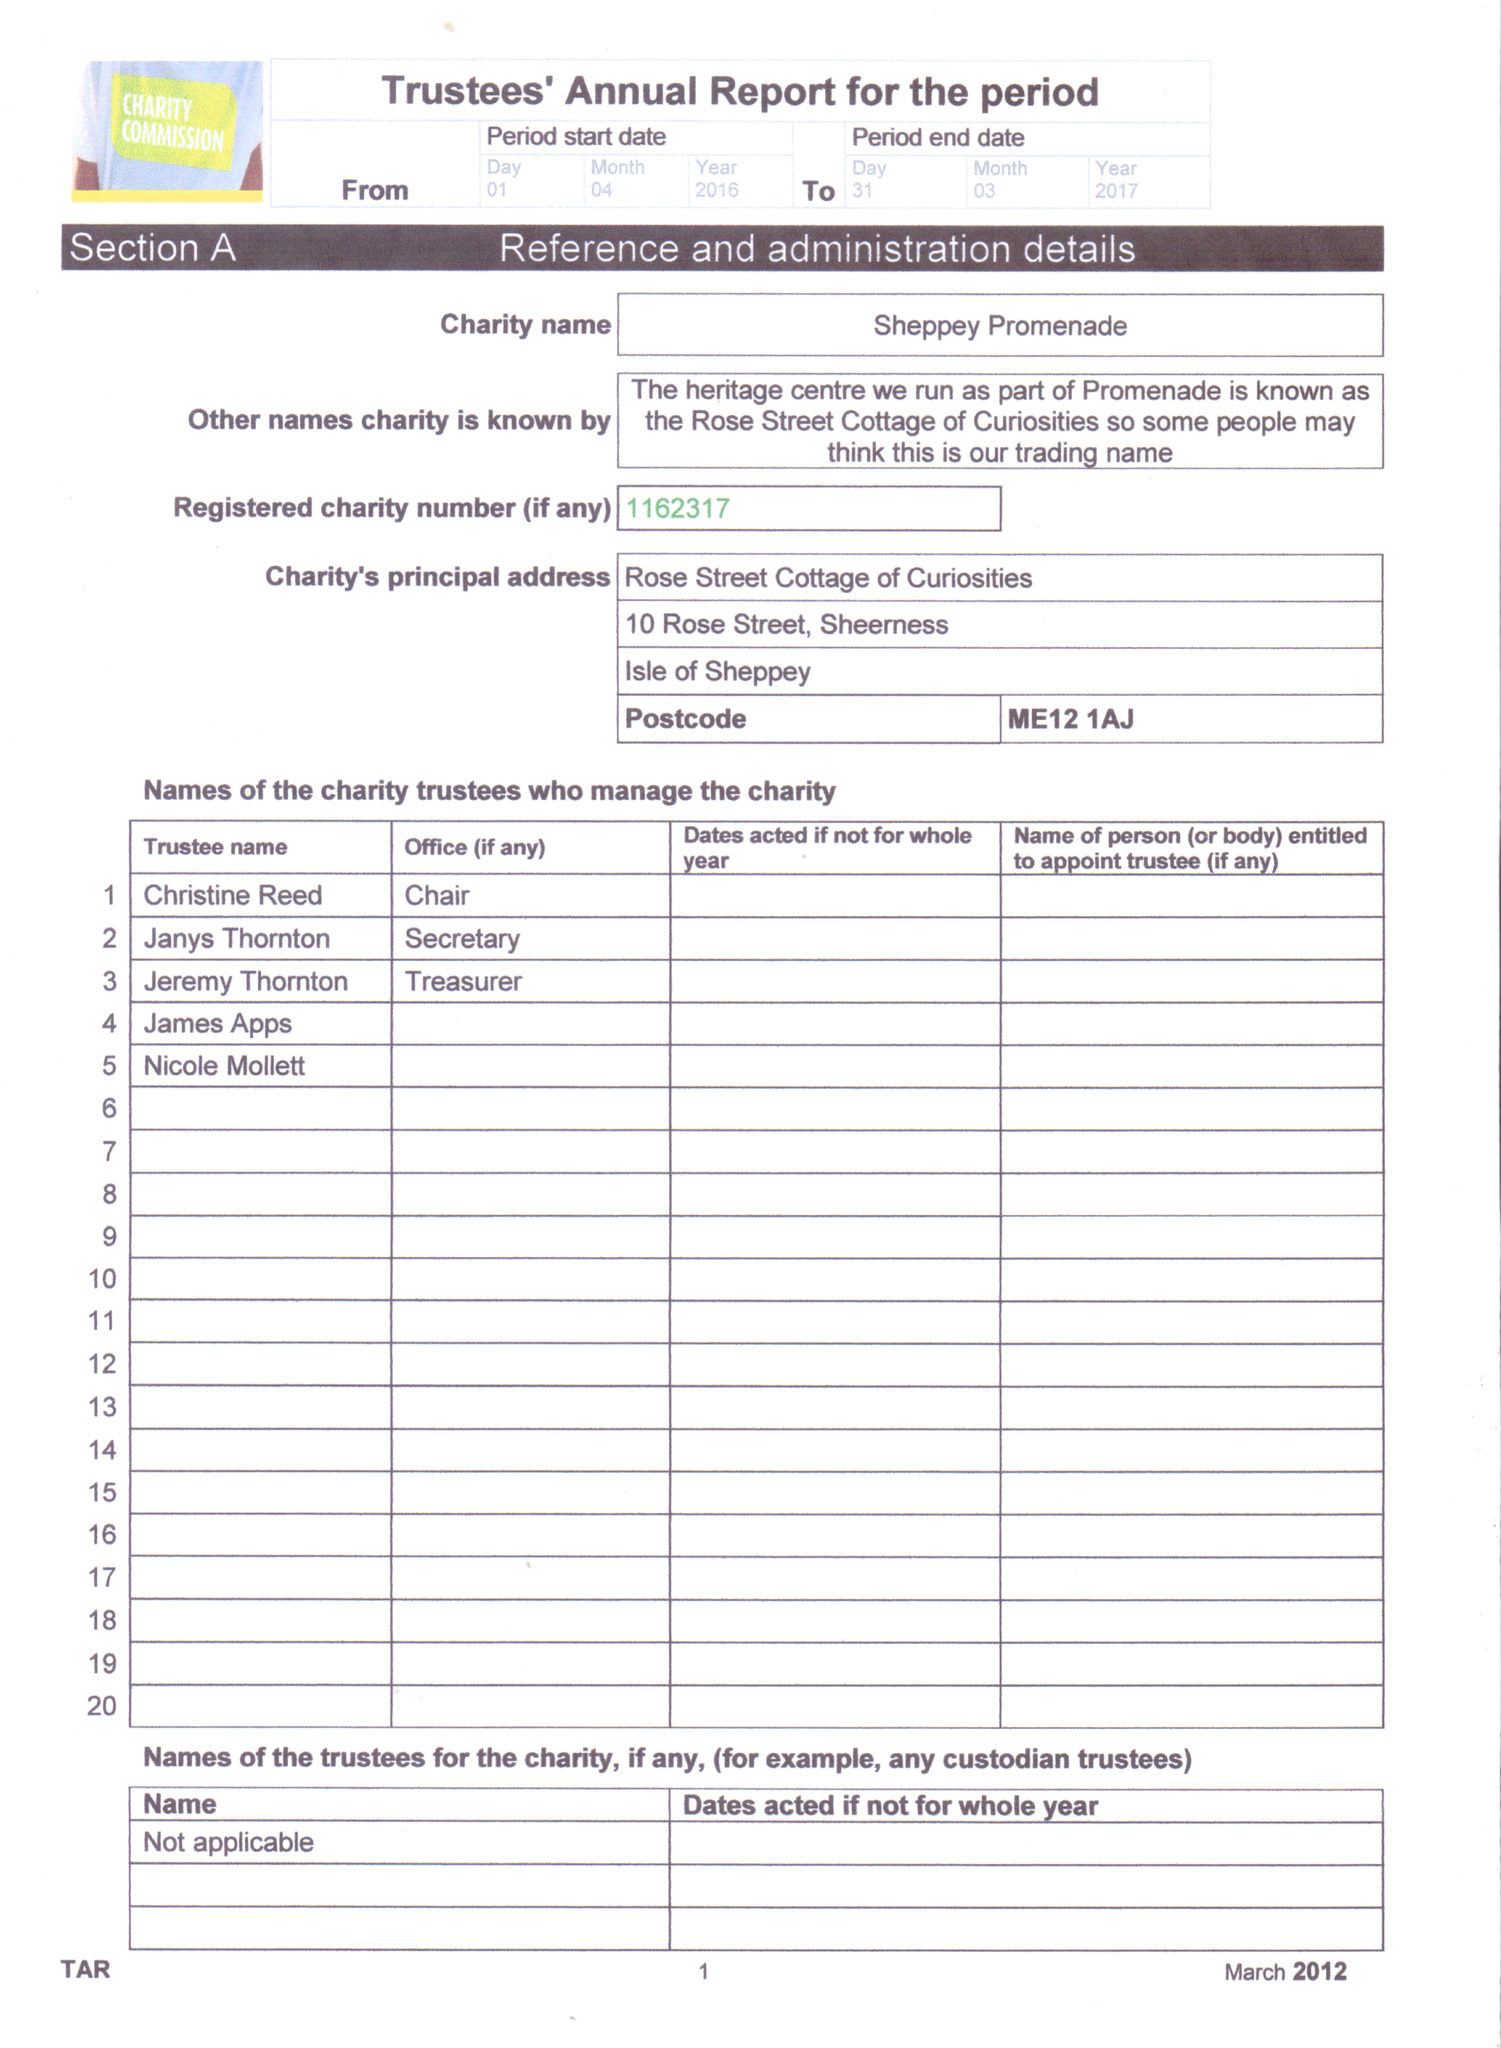What is the value for the charity_name?
Answer the question using a single word or phrase. Sheppey Promenade 